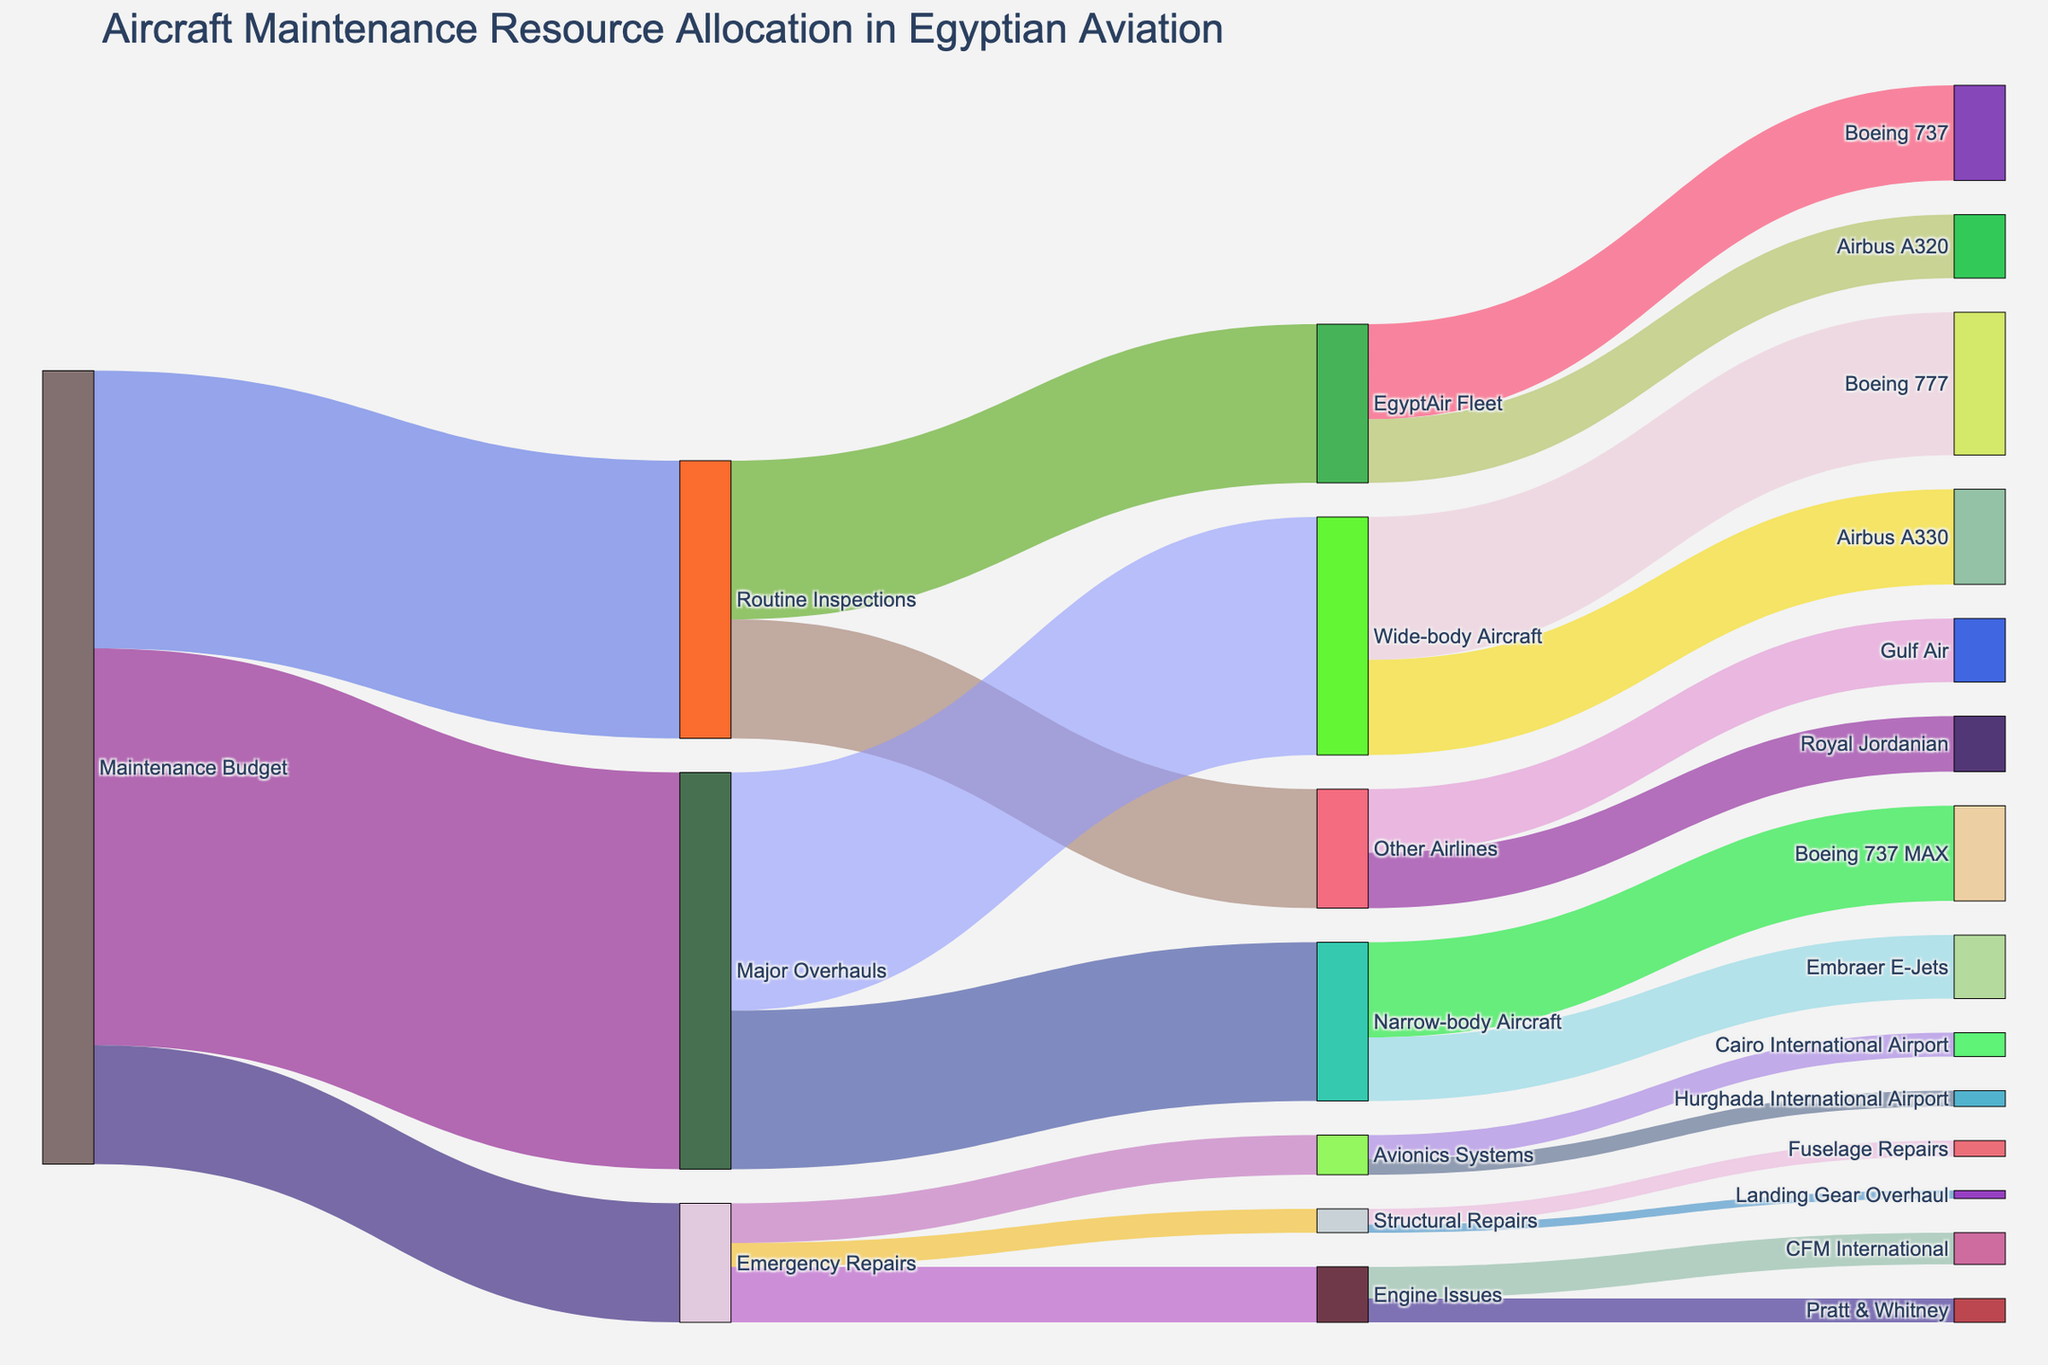What is the total Maintenance Budget allocated for routine inspections, major overhauls, and emergency repairs? The sum of the values allocated for routine inspections, major overhauls, and emergency repairs equals 3500000 + 5000000 + 1500000, which is 10000000.
Answer: 10000000 How much of the Routine Inspections budget is allocated to the EgyptAir Fleet? From the figure, the Routine Inspections budget allocated to the EgyptAir Fleet is shown as 2000000.
Answer: 2000000 Which type of aircraft receives the highest allocation in Major Overhauls? The figure shows that Wide-body Aircraft receive 3000000, while Narrow-body Aircraft receive 2000000. Wide-body Aircraft thus have the highest allocation.
Answer: Wide-body Aircraft What is the combined budget for handling Engine Issues under Emergency Repairs? Summing the values allocated for Engine Issues, which are handled by CFM International and Pratt & Whitney, gives us 400000 + 300000, resulting in 700000.
Answer: 700000 Which maintenance area under Emergency Repairs receives the least budget allocation? The figure indicates that Structural Repairs receive 300000, Avionics Systems receive 500000, and Engine Issues receive 700000. Structural Repairs have the least allocation.
Answer: Structural Repairs How does the allocation for Avionics Systems under Emergency Repairs compare between Cairo International Airport and Hurghada International Airport? Cairo International Airport receives 300000, while Hurghada International Airport receives 200000. Therefore, Cairo International Airport gets more budget for Avionics Systems.
Answer: Cairo International Airport What is the total budget allocated to EgyptAir’s Boeing 737 under Routine Inspections? From the figure, EgyptAir’s Boeing 737 under Routine Inspections is allocated 1200000.
Answer: 1200000 How much budget is allocated overall to handle maintenance for Other Airlines besides EgyptAir? The figure shows that Other Airlines have a total allocation of 1500000, which is divided between Gulf Air with 800000 and Royal Jordanian with 700000.
Answer: 1500000 What's the difference between the maintenance budget for a Boeing 777 and an Airbus A330 within Wide-body Aircraft Major Overhauls? The budget for Boeing 777 is 1800000, and for Airbus A330, it's 1200000. The difference is 1800000 - 1200000, which is 600000.
Answer: 600000 Which airport receives a higher budget allocation for Avionics Systems repairs? The figure indicates that Cairo International Airport receives 300000, while Hurghada International Airport receives 200000. Cairo International Airport, therefore, receives a higher budget allocation.
Answer: Cairo International Airport 